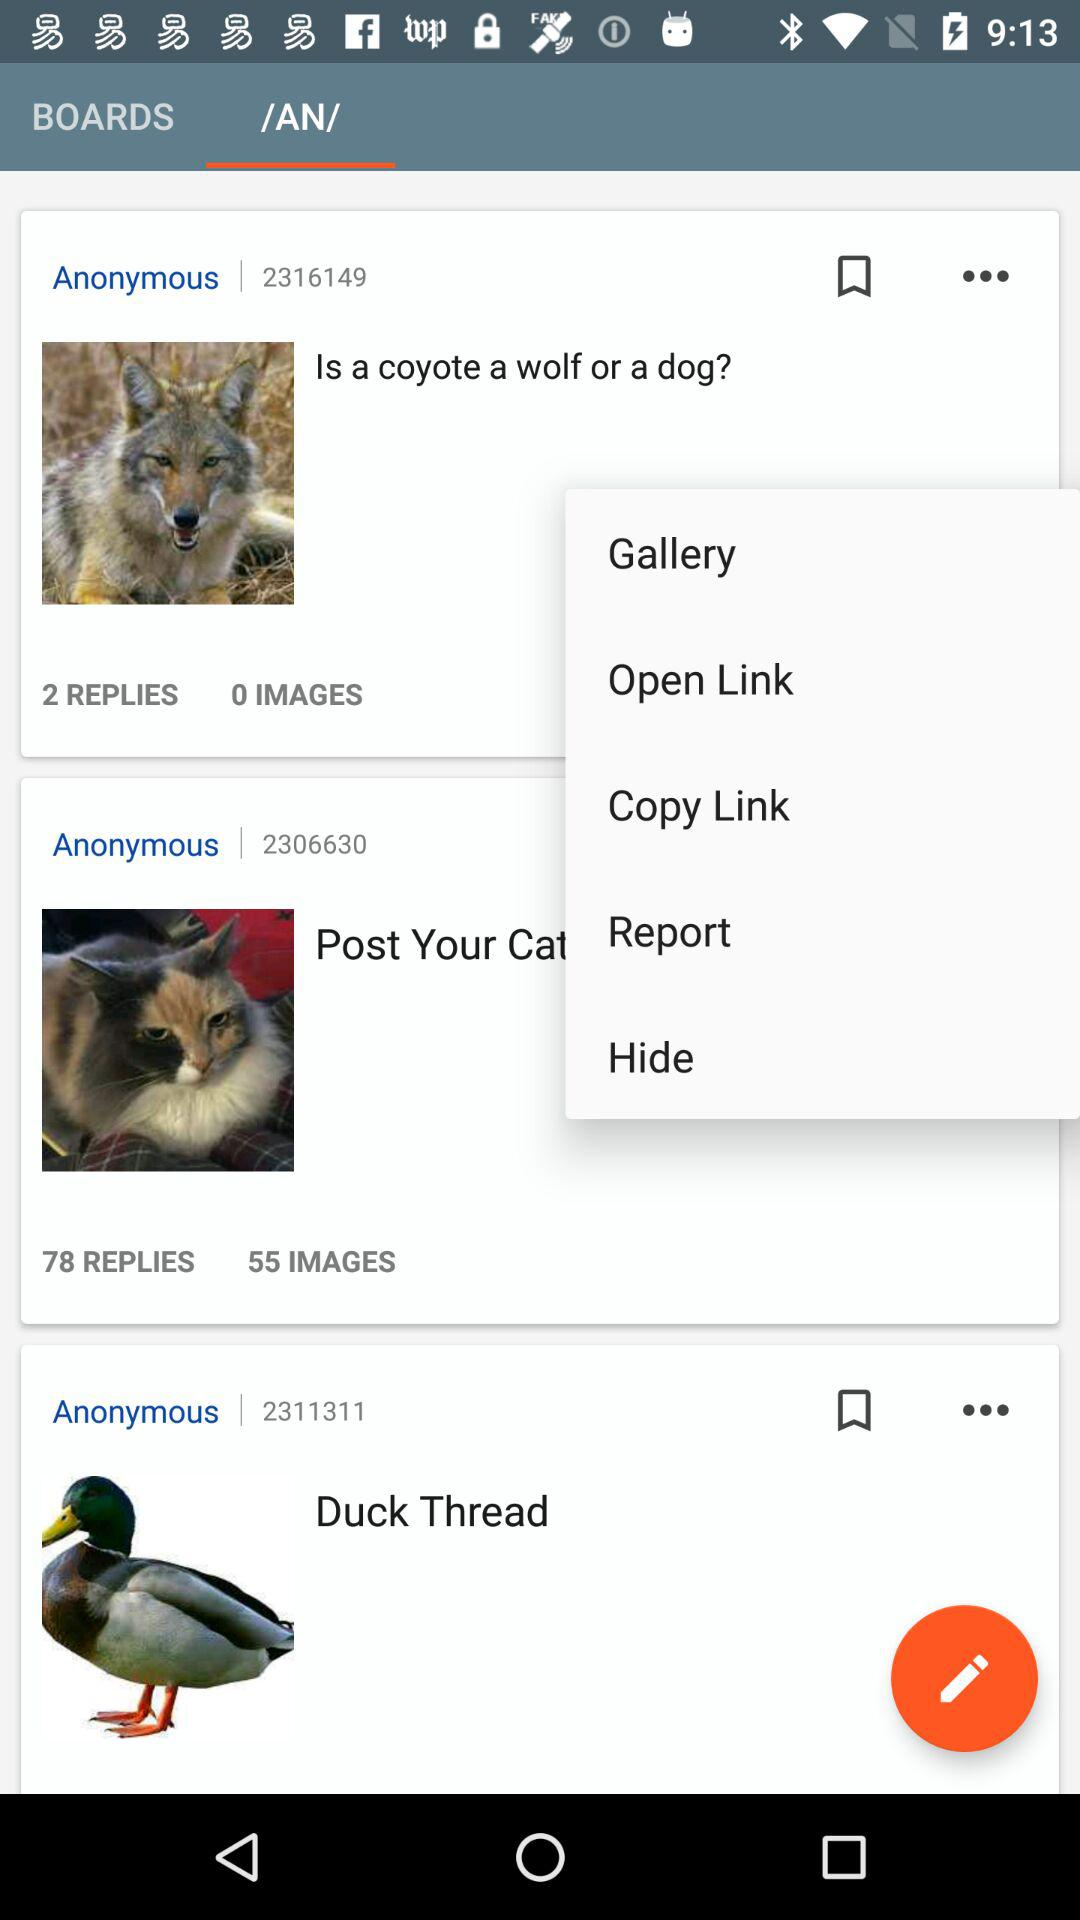How many images in total are there in "Is a coyote a wolf or a dog?"? There are total 0 images. 